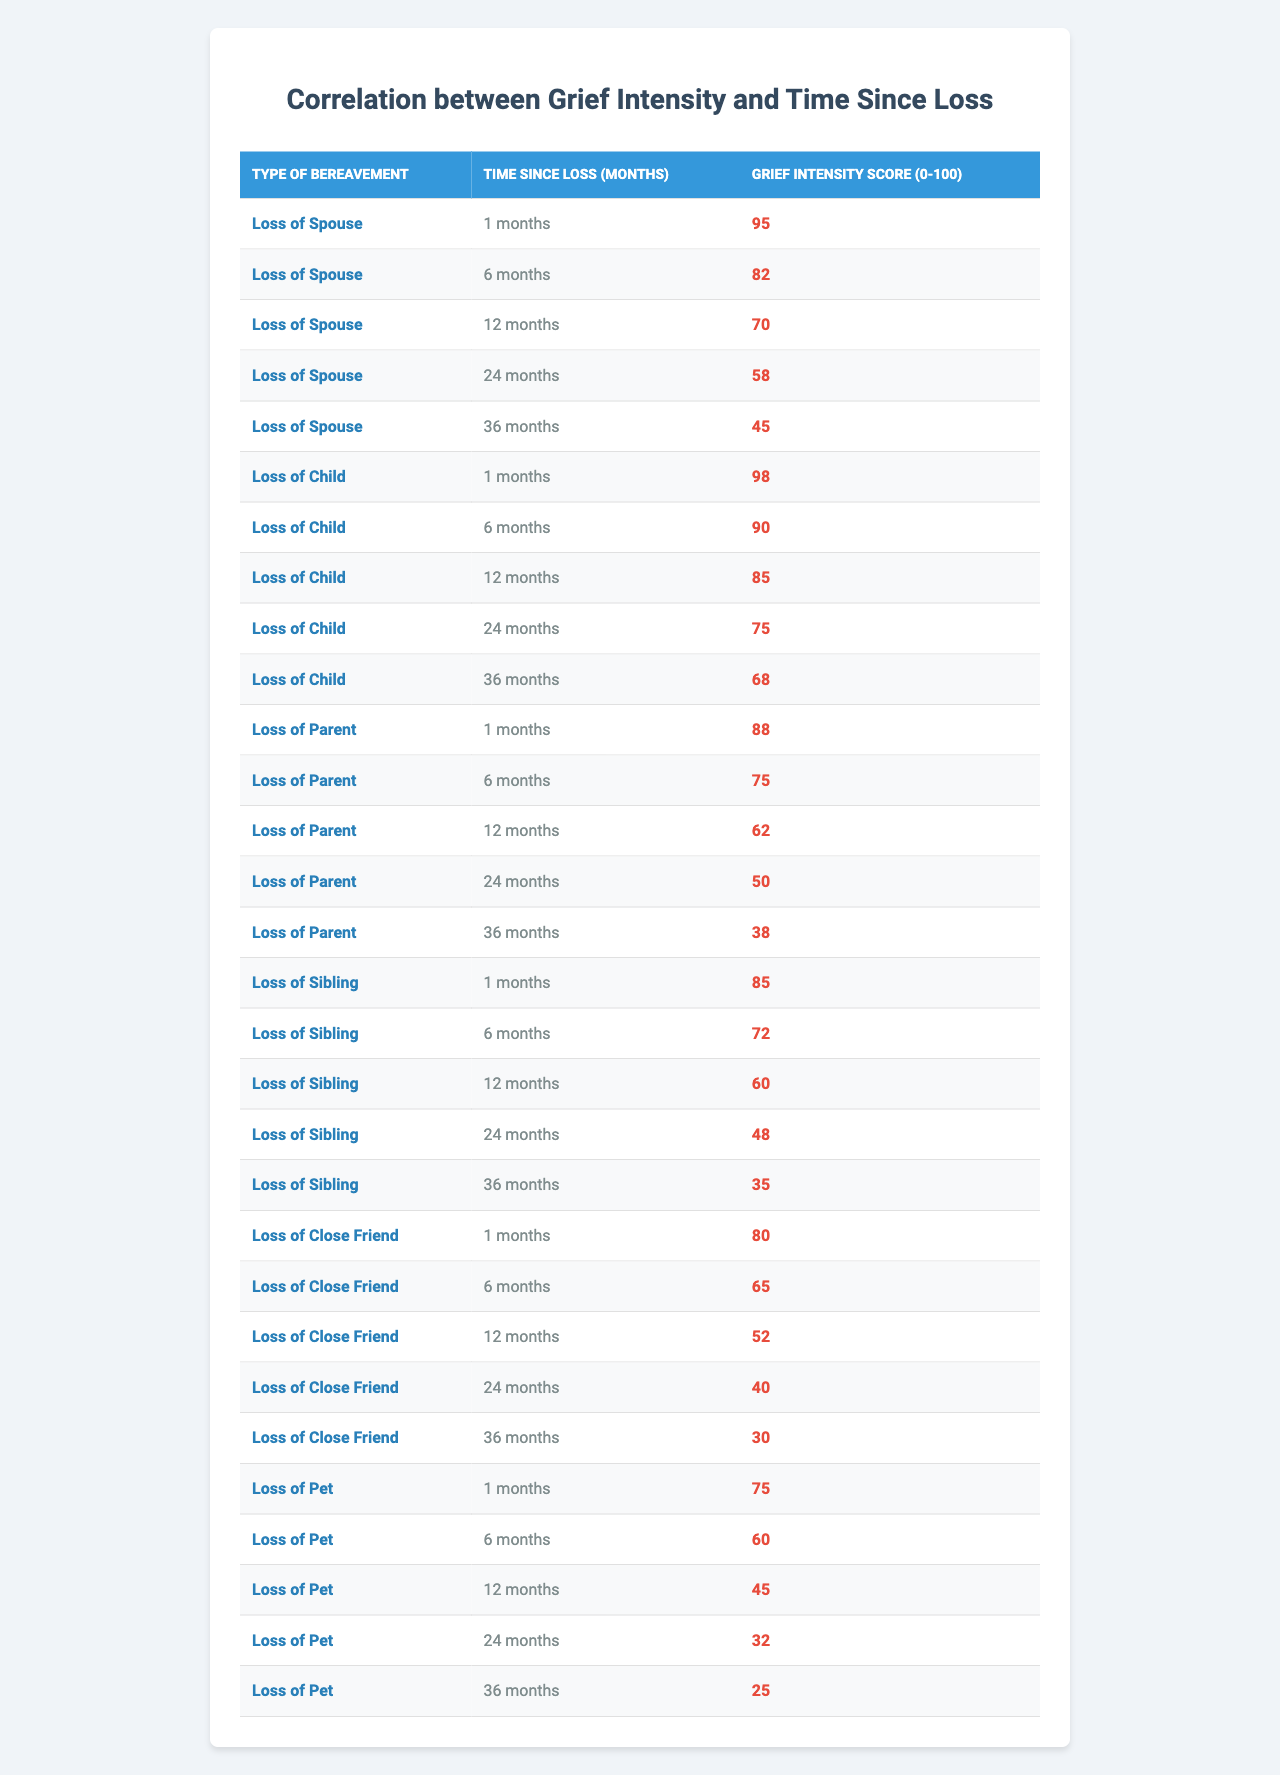What is the grief intensity score for the loss of a spouse after 12 months? For the loss of a spouse, the table shows a grief intensity score of 70 after 12 months.
Answer: 70 What is the score for grief intensity after 36 months for the loss of a child? The table indicates that the grief intensity score for the loss of a child after 36 months is 68.
Answer: 68 How does the grief intensity score for losing a parent change from 1 month to 36 months? The score for losing a parent starts at 88 at 1 month and decreases to 38 at 36 months, showing a change of 50 points.
Answer: 50 Which type of bereavement shows the highest grief intensity score at 6 months? The loss of a child shows the highest score at 90 after 6 months, compared to other types of bereavement in the table.
Answer: Loss of Child What is the average grief intensity score for the loss of a sibling over the 5 time points recorded? The grief intensity scores for the loss of a sibling are 85, 72, 60, 48, and 35. The total is 300, and averaging it over 5 gives 300/5 = 60.
Answer: 60 Is there any type of bereavement that maintains a grief intensity score above 50 after 24 months? The scores indicate that the loss of a spouse (58), loss of a child (75), and loss of a parent (50) are all above 50 after 24 months.
Answer: Yes What is the difference in grief intensity scores for losing a close friend between 1 month and 36 months? The score for losing a close friend at 1 month is 80, and at 36 months, it is 30, resulting in a difference of 50 points.
Answer: 50 For which type of bereavement does grief intensity decline the most dramatically from 1 month to 36 months? The loss of a pet declines from 75 to 25, totaling a decline of 50 points, which is the most significant drop among all bereavements.
Answer: Loss of Pet What is the median grief intensity score for all types of bereavement after 12 months? The scores after 12 months are 70 (spouse), 85 (child), 62 (parent), 60 (sibling), and 52 (friend). When arranged, the median is 62.
Answer: 62 Do all types of bereavement show a decrease in grief intensity over time? Yes, all bereavement types show a consistent decrease in scores as time progresses in the provided data.
Answer: Yes 